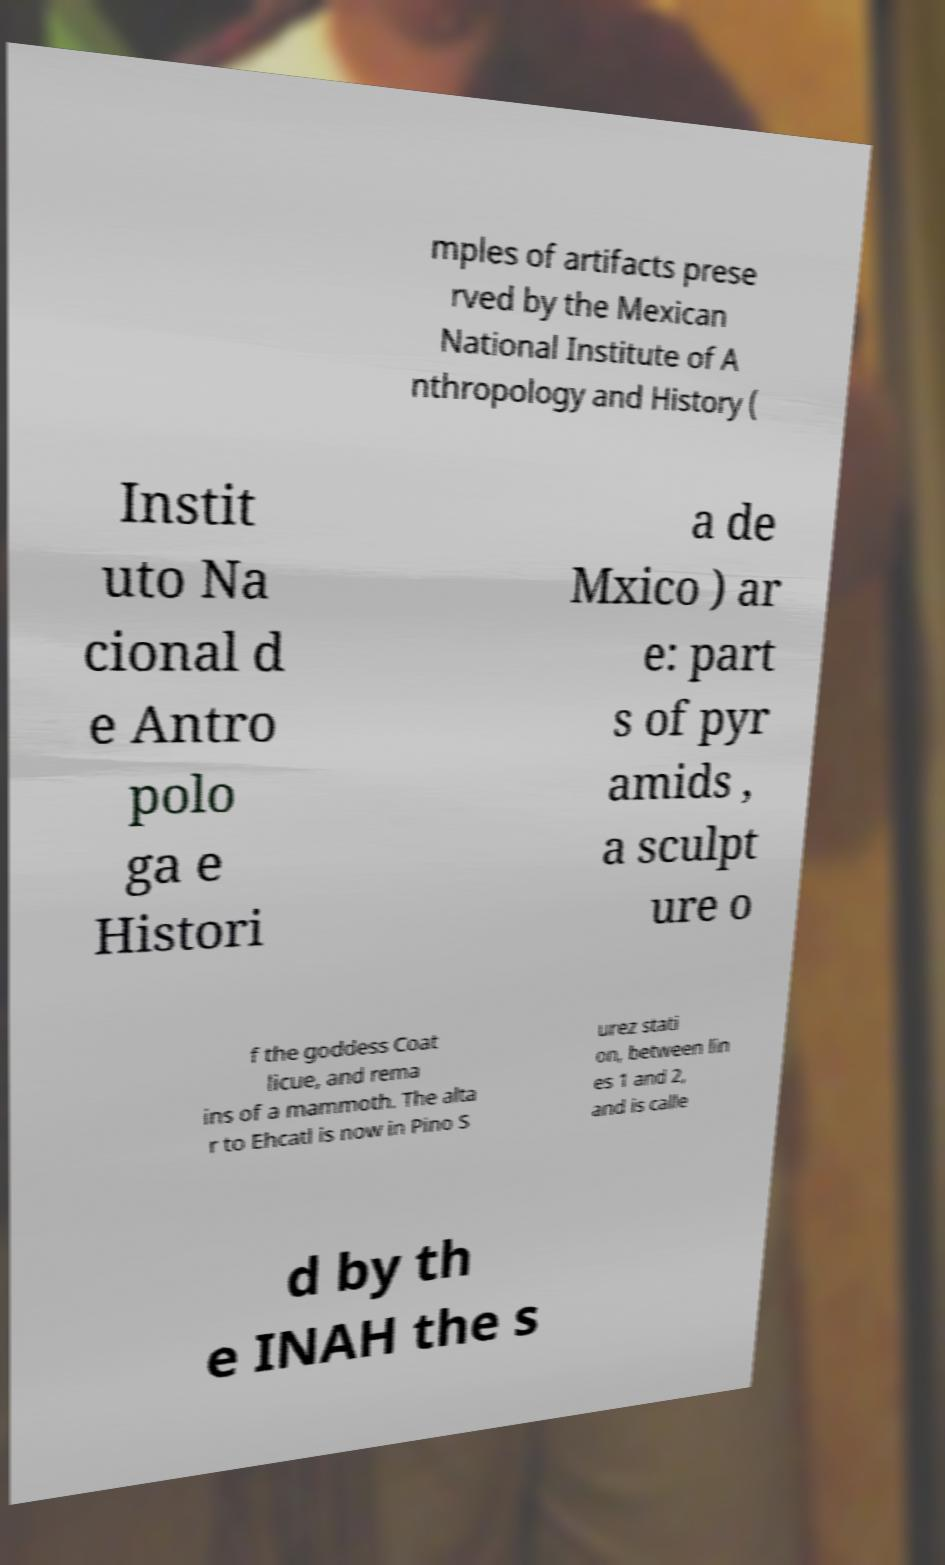Can you read and provide the text displayed in the image?This photo seems to have some interesting text. Can you extract and type it out for me? mples of artifacts prese rved by the Mexican National Institute of A nthropology and History ( Instit uto Na cional d e Antro polo ga e Histori a de Mxico ) ar e: part s of pyr amids , a sculpt ure o f the goddess Coat licue, and rema ins of a mammoth. The alta r to Ehcatl is now in Pino S urez stati on, between lin es 1 and 2, and is calle d by th e INAH the s 